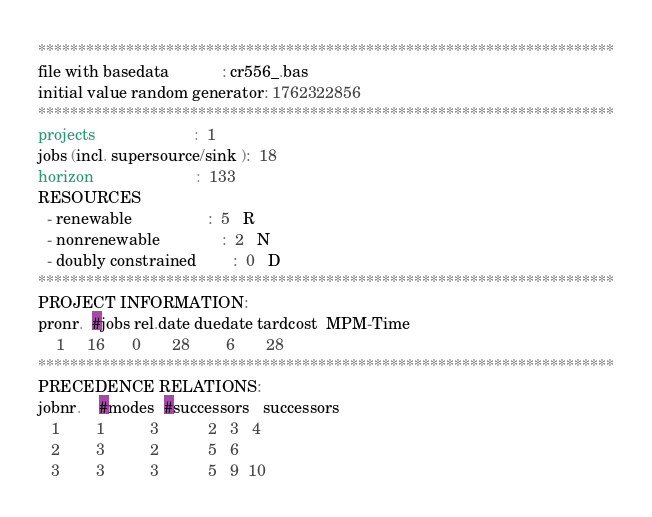<code> <loc_0><loc_0><loc_500><loc_500><_ObjectiveC_>************************************************************************
file with basedata            : cr556_.bas
initial value random generator: 1762322856
************************************************************************
projects                      :  1
jobs (incl. supersource/sink ):  18
horizon                       :  133
RESOURCES
  - renewable                 :  5   R
  - nonrenewable              :  2   N
  - doubly constrained        :  0   D
************************************************************************
PROJECT INFORMATION:
pronr.  #jobs rel.date duedate tardcost  MPM-Time
    1     16      0       28        6       28
************************************************************************
PRECEDENCE RELATIONS:
jobnr.    #modes  #successors   successors
   1        1          3           2   3   4
   2        3          2           5   6
   3        3          3           5   9  10</code> 